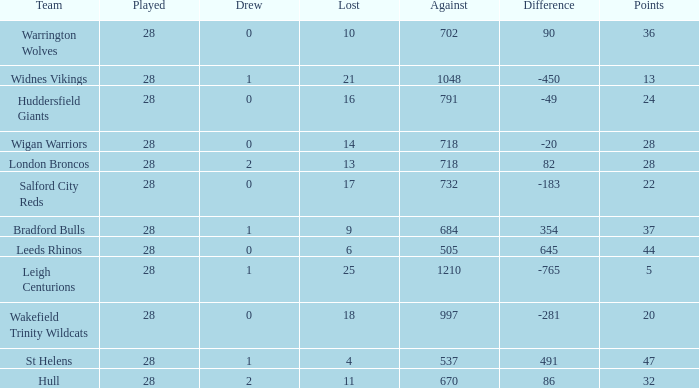What is the most lost games for the team with a difference smaller than 86 and points of 32? None. 